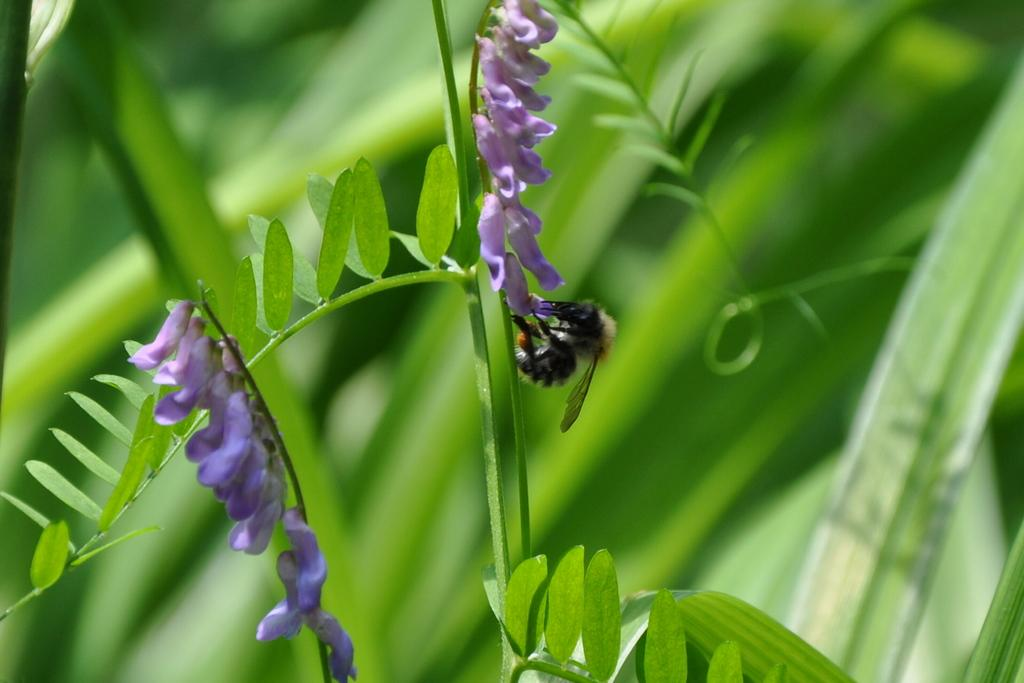What is on the flower in the image? There is an insect on the flower in the image. What color is the flower? The flower is violet. What other plant elements are visible in the image? There are green leaves in the image. What color is the background of the image? The background is green. What type of suggestion can be seen written on the banana in the image? There is no banana present in the image, and therefore no suggestions can be seen written on it. 